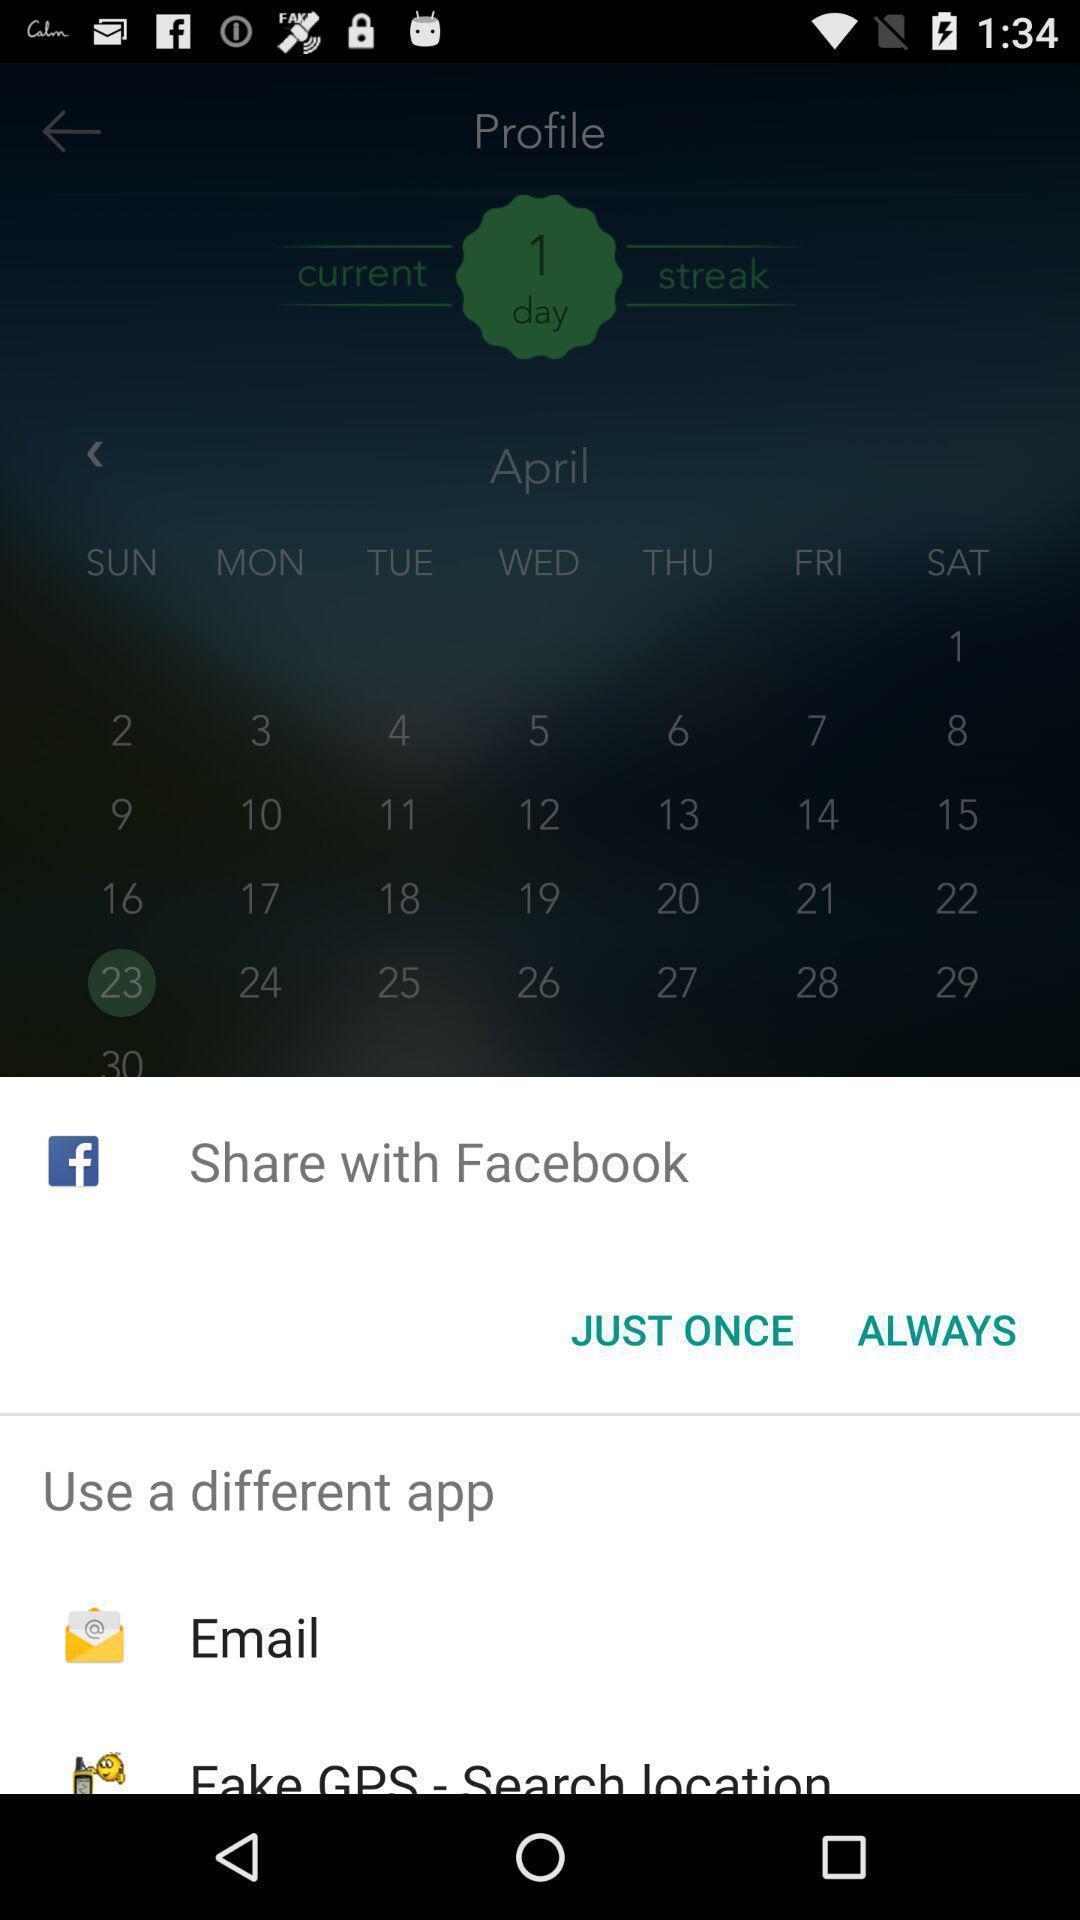Explain the elements present in this screenshot. Pop-up shows to share with multiple applications. 